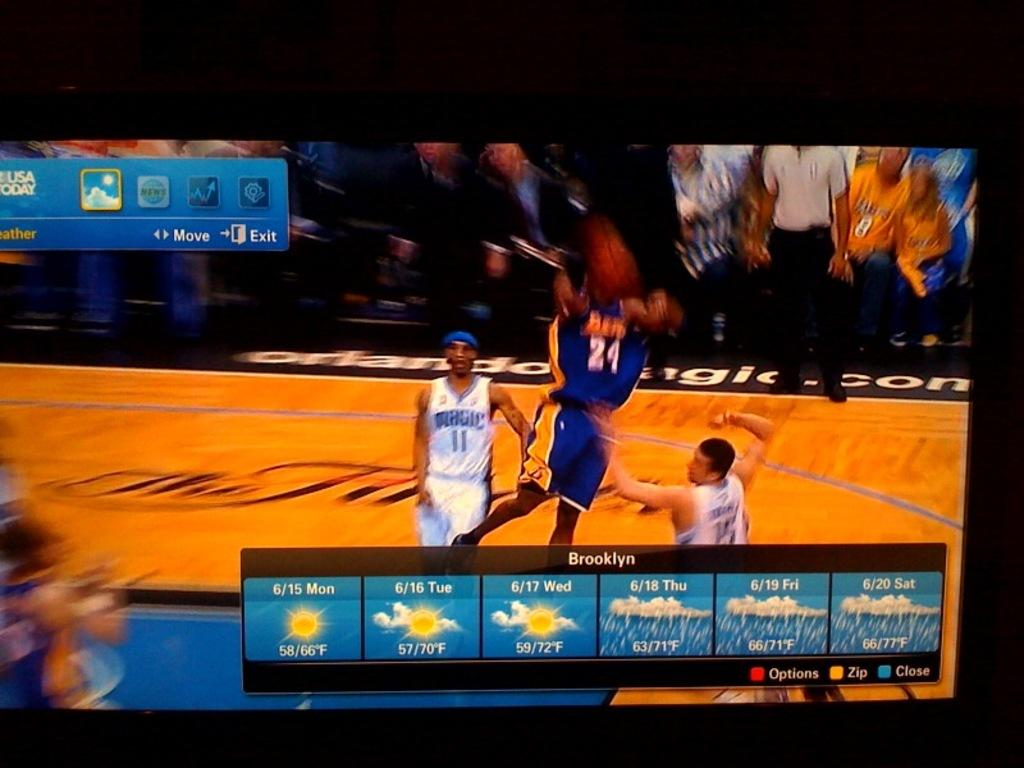<image>
Write a terse but informative summary of the picture. A basketball game plays on a TV as the weather for Brooklyn is displayed in the foreground. 